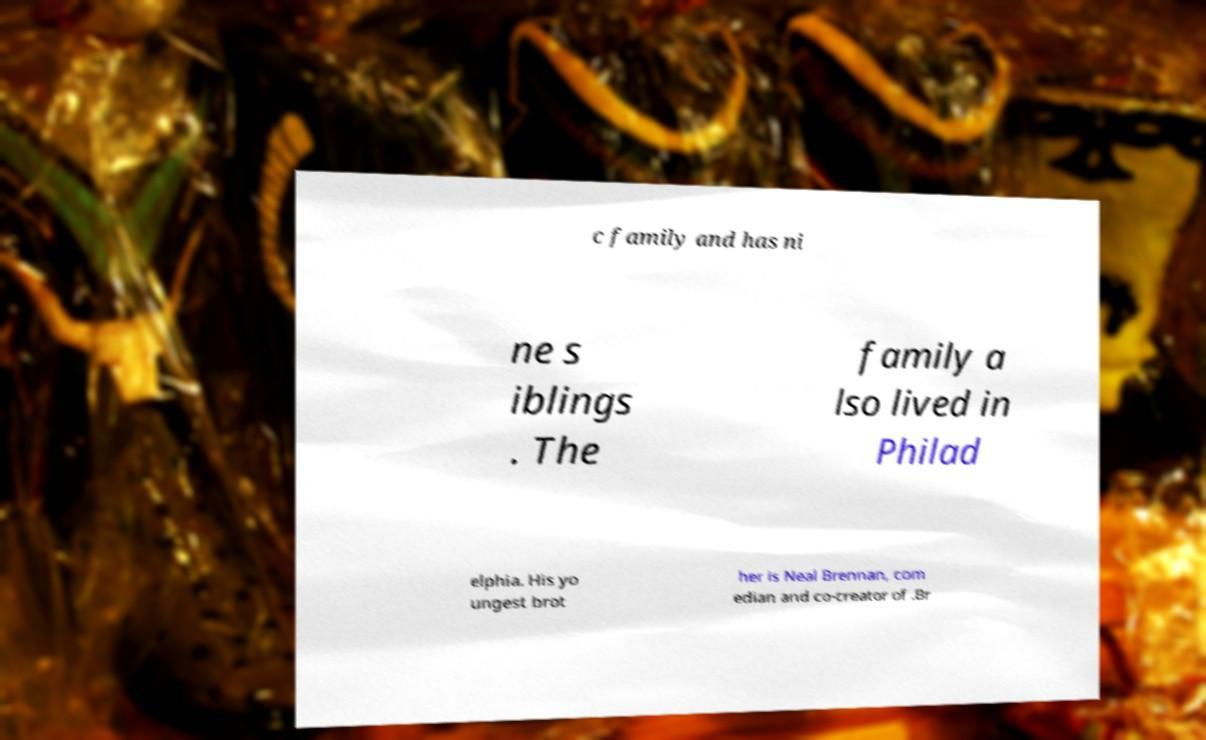Can you accurately transcribe the text from the provided image for me? c family and has ni ne s iblings . The family a lso lived in Philad elphia. His yo ungest brot her is Neal Brennan, com edian and co-creator of .Br 